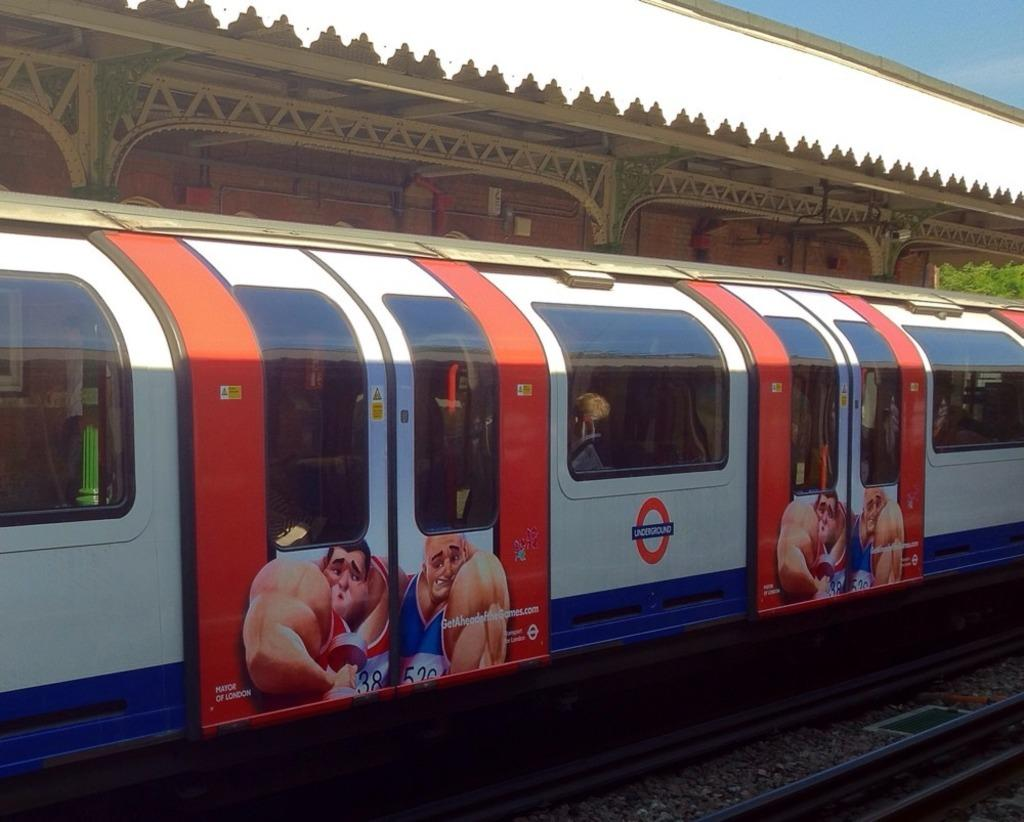What is the main subject of the image? The main subject of the image is a train. What can be seen on the train? The train has images on it. What is the train positioned on in the image? There is a train track visible in the image. What structure is present near the train? There is a platform in the image. What type of material is used for the frames in the image? Metal frames are present in the image. What is visible in the background of the image? The sky is visible in the image. What type of bean is being used to balance the train in the image? There is no bean present in the image, and the train is not being balanced by any object. What songs can be heard playing from the train in the image? There is no indication of any music or songs in the image; it only shows a train, train track, platform, metal frames, and the sky. 